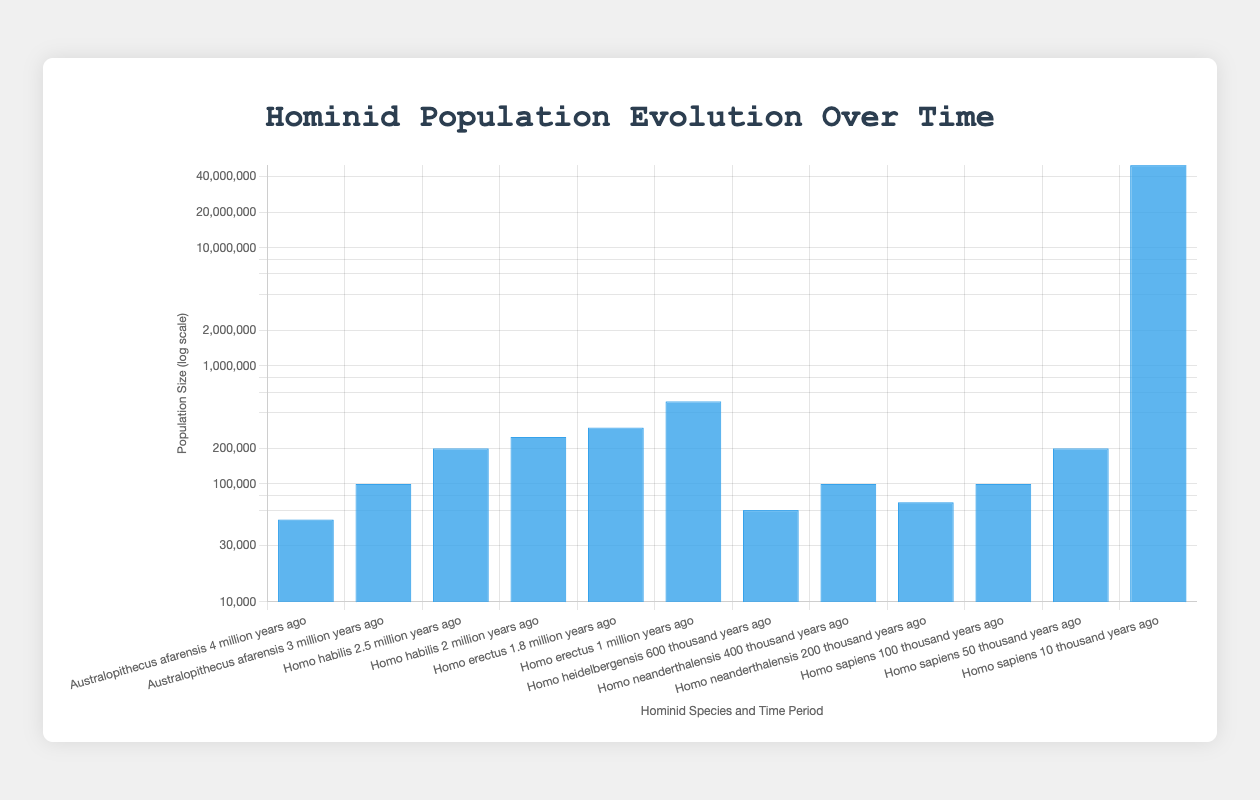What is the population size of "Homo sapiens" 10 thousand years ago? To find the population of "Homo sapiens" 10 thousand years ago, look at the relevant label and the corresponding bar height which indicates the population size. The bar for "10 thousand years ago" is at 50,000,000.
Answer: 50,000,000 Which hominid species had a population size of 100,000 during their existence? Check the bars to see which species have a population size of 100,000. "Australopithecus afarensis" at 3 million years ago and "Homo neanderthalensis" at 400 thousand years ago both have population sizes of 100,000.
Answer: Australopithecus afarensis and Homo neanderthalensis How does the population size of "Homo habilis" 2.5 million years ago compare to 2 million years ago? Compare the heights of the bars for "Homo habilis" at 2.5 million years ago and 2 million years ago. The population increases from 200,000 to 250,000.
Answer: Larger at 2 million years ago by 50,000 Add the population sizes for "Homo sapiens" 100 thousand years ago, 50 thousand years ago, and 10 thousand years ago. Sum the values given for these periods: 100,000 (100 thousand years ago) + 200,000 (50 thousand years ago) + 50,000,000 (10 thousand years ago). This totals up to 50,300,000.
Answer: 50,300,000 Which hominid species shows the largest increase in population size over their documented periods? Compare the population sizes for each hominid over their documented periods. "Homo sapiens" shows the largest increase from 100,000 to 50,000,000 over the period of 100 thousand to 10 thousand years ago.
Answer: Homo sapiens What was the population size difference between "Homo heidelbergensis" and "Homo erectus" at 1 million years ago? Identify the population sizes for each species at their indicated periods. "Homo heidelbergensis" at 600 thousand years ago has a population size of 60,000, while "Homo erectus" at 1 million years ago has 500,000. The difference is 500,000 - 60,000 = 440,000.
Answer: 440,000 What is the average population size of all hominid species at their respective periods? To calculate the average, add up all the population sizes and divide by the number of observations: (50,000 + 100,000 + 200,000 + 250,000 + 300,000 + 500,000 + 60,000 + 100,000 + 70,000 + 100,000 + 200,000 + 50,000,000) / 12 = 52,930,000 / 12. This totals approximately 4,410,833.
Answer: 4,410,833 Which time period for "Homo neanderthalensis" had the lesser population size? Compare the two periods for "Homo neanderthalensis": 400 thousand years ago at 100,000 and 200 thousand years ago at 70,000. The lesser one is 200 thousand years ago.
Answer: 200 thousand years ago 